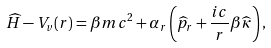Convert formula to latex. <formula><loc_0><loc_0><loc_500><loc_500>\widehat { H } - V _ { v } ( r ) = \beta m c ^ { 2 } + \alpha _ { r } \left ( \widehat { p } _ { r } + \frac { i c } { r } \beta \widehat { \kappa } \right ) ,</formula> 